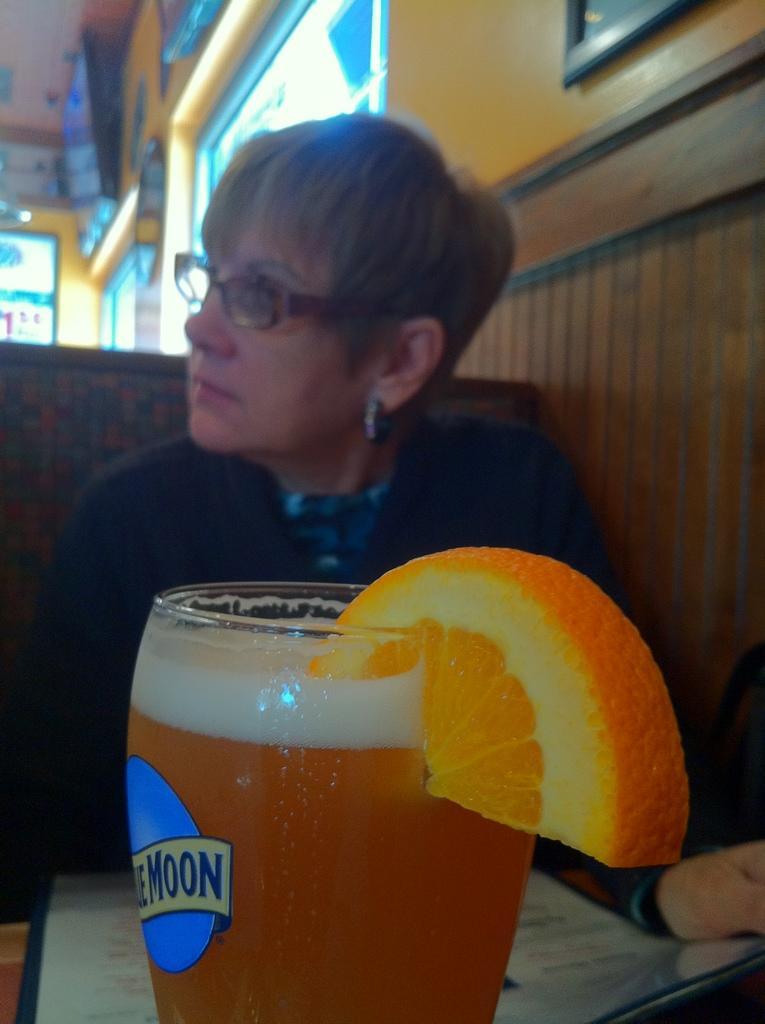In one or two sentences, can you explain what this image depicts? Here we can see a woman and she has spectacles. There is a glass with drink and an orange slice. In the background we can see wall and frames. 